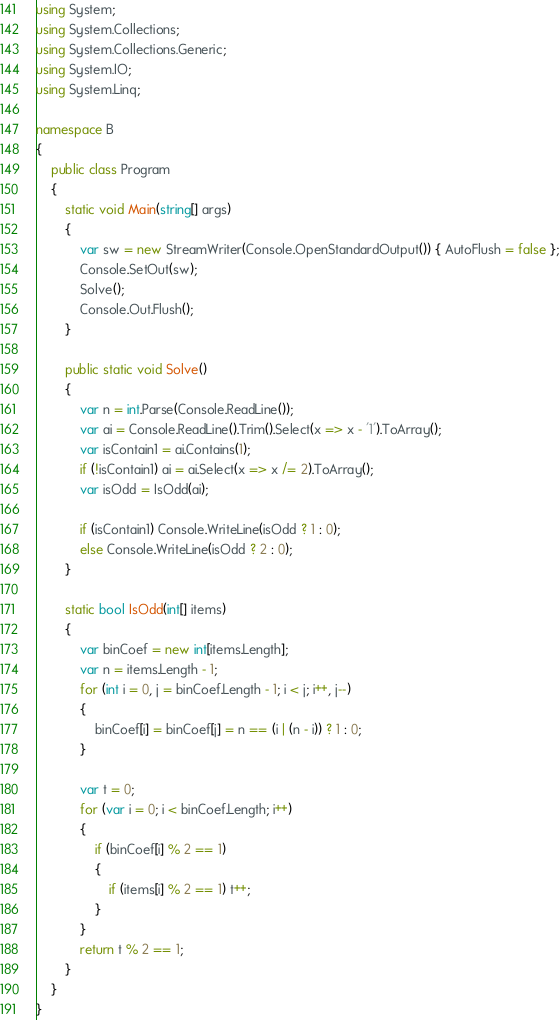Convert code to text. <code><loc_0><loc_0><loc_500><loc_500><_C#_>using System;
using System.Collections;
using System.Collections.Generic;
using System.IO;
using System.Linq;

namespace B
{
    public class Program
    {
        static void Main(string[] args)
        {
            var sw = new StreamWriter(Console.OpenStandardOutput()) { AutoFlush = false };
            Console.SetOut(sw);
            Solve();
            Console.Out.Flush();
        }

        public static void Solve()
        {
            var n = int.Parse(Console.ReadLine());
            var ai = Console.ReadLine().Trim().Select(x => x - '1').ToArray();
            var isContain1 = ai.Contains(1);
            if (!isContain1) ai = ai.Select(x => x /= 2).ToArray();
            var isOdd = IsOdd(ai);

            if (isContain1) Console.WriteLine(isOdd ? 1 : 0);
            else Console.WriteLine(isOdd ? 2 : 0);
        }

        static bool IsOdd(int[] items)
        {
            var binCoef = new int[items.Length];
            var n = items.Length - 1;
            for (int i = 0, j = binCoef.Length - 1; i < j; i++, j--)
            {
                binCoef[i] = binCoef[j] = n == (i | (n - i)) ? 1 : 0;
            }

            var t = 0;
            for (var i = 0; i < binCoef.Length; i++)
            {
                if (binCoef[i] % 2 == 1)
                {
                    if (items[i] % 2 == 1) t++;
                }
            }
            return t % 2 == 1;
        }
    }
}
</code> 